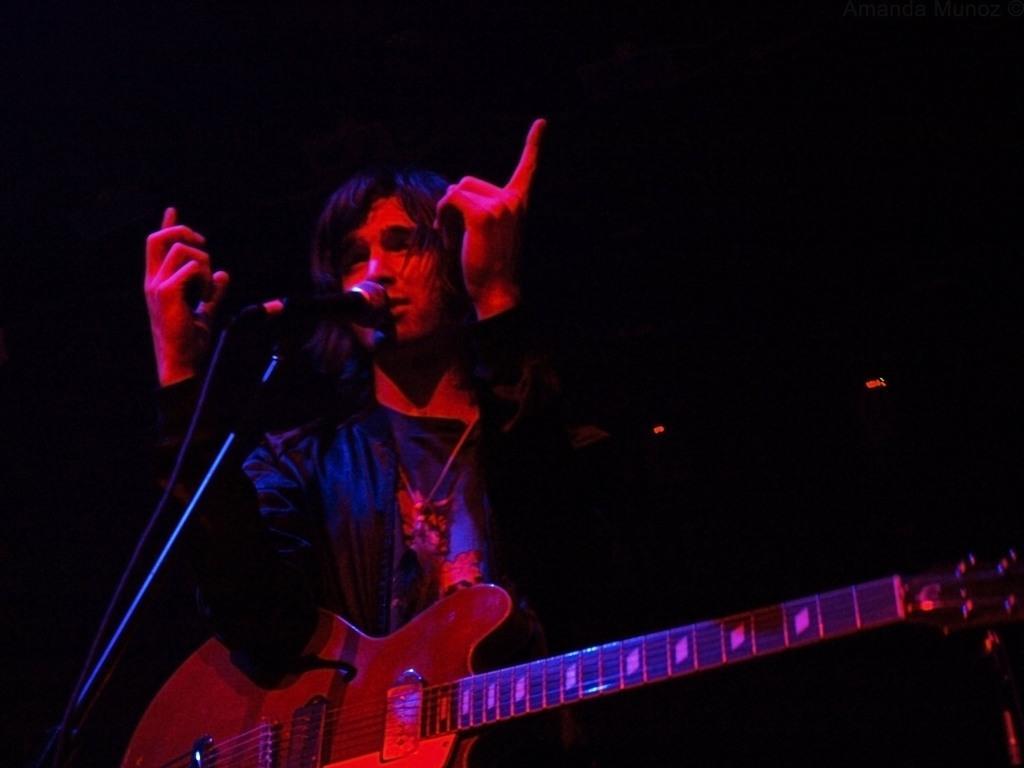Could you give a brief overview of what you see in this image? Here is the man standing and singing a song. He is holding guitar. This is the mic attached to the mike stand. The background is dark. 